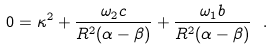Convert formula to latex. <formula><loc_0><loc_0><loc_500><loc_500>0 = \kappa ^ { 2 } + \frac { \omega _ { 2 } c } { R ^ { 2 } ( \alpha - \beta ) } + \frac { \omega _ { 1 } b } { R ^ { 2 } ( \alpha - \beta ) } \ .</formula> 